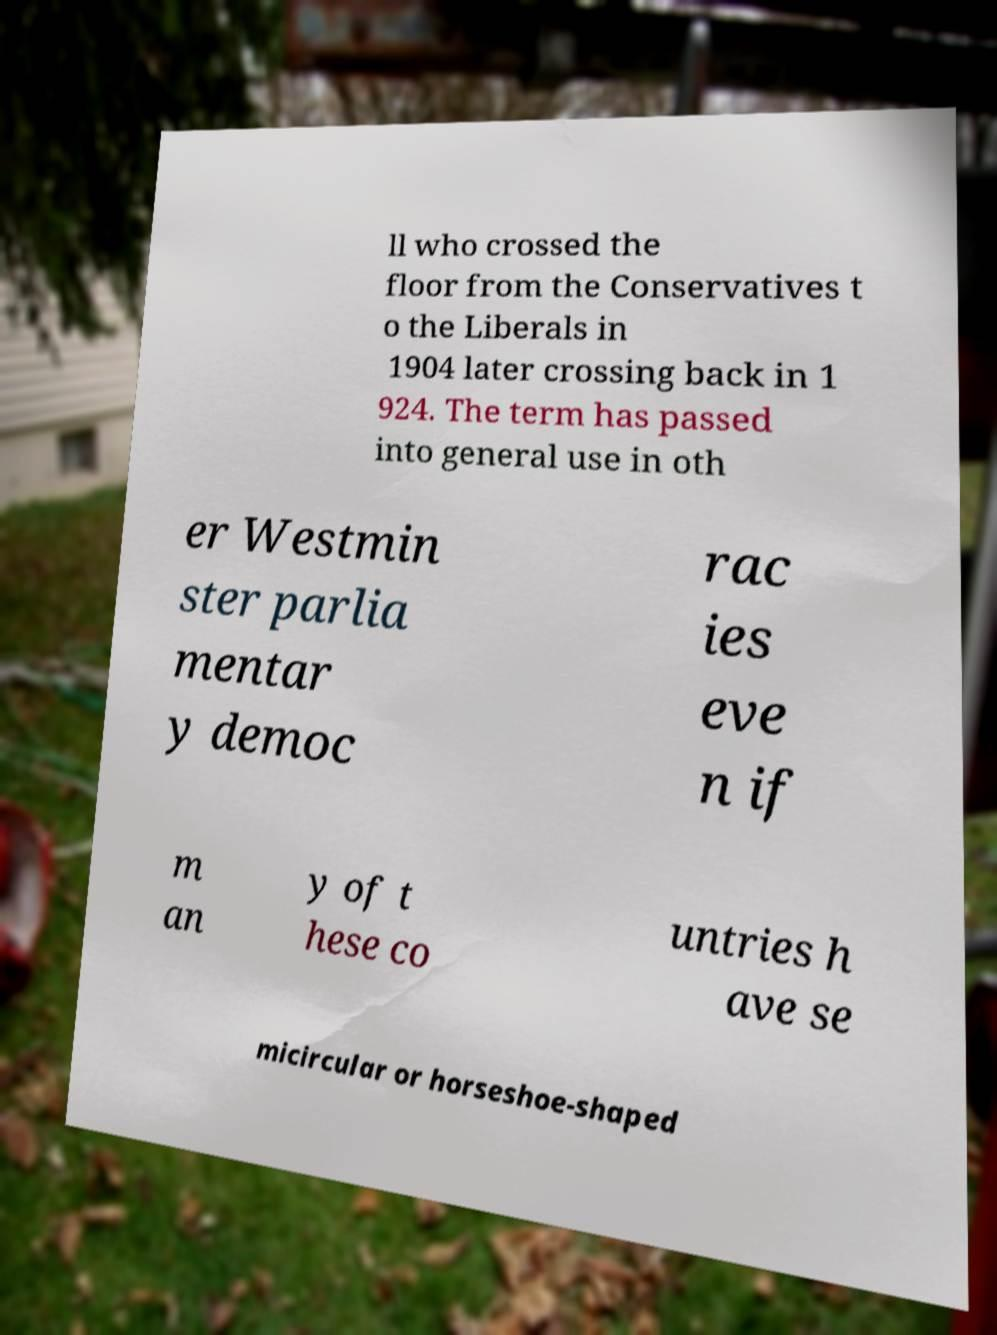Can you accurately transcribe the text from the provided image for me? ll who crossed the floor from the Conservatives t o the Liberals in 1904 later crossing back in 1 924. The term has passed into general use in oth er Westmin ster parlia mentar y democ rac ies eve n if m an y of t hese co untries h ave se micircular or horseshoe-shaped 